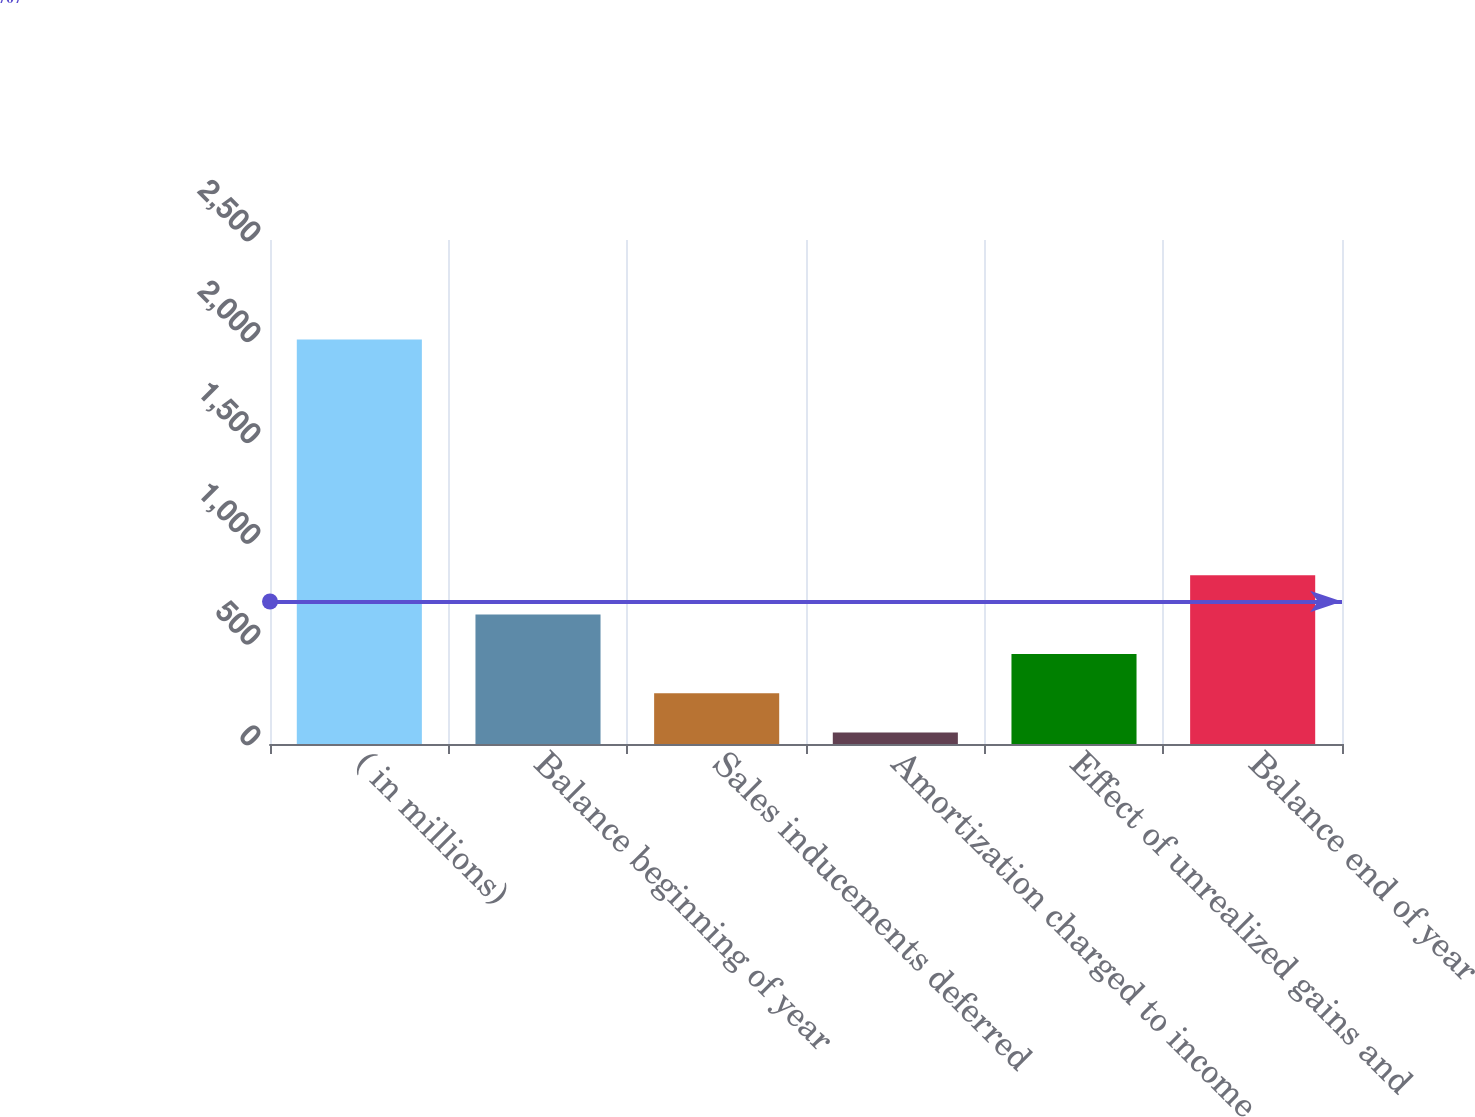Convert chart to OTSL. <chart><loc_0><loc_0><loc_500><loc_500><bar_chart><fcel>( in millions)<fcel>Balance beginning of year<fcel>Sales inducements deferred<fcel>Amortization charged to income<fcel>Effect of unrealized gains and<fcel>Balance end of year<nl><fcel>2007<fcel>642<fcel>252<fcel>57<fcel>447<fcel>837<nl></chart> 